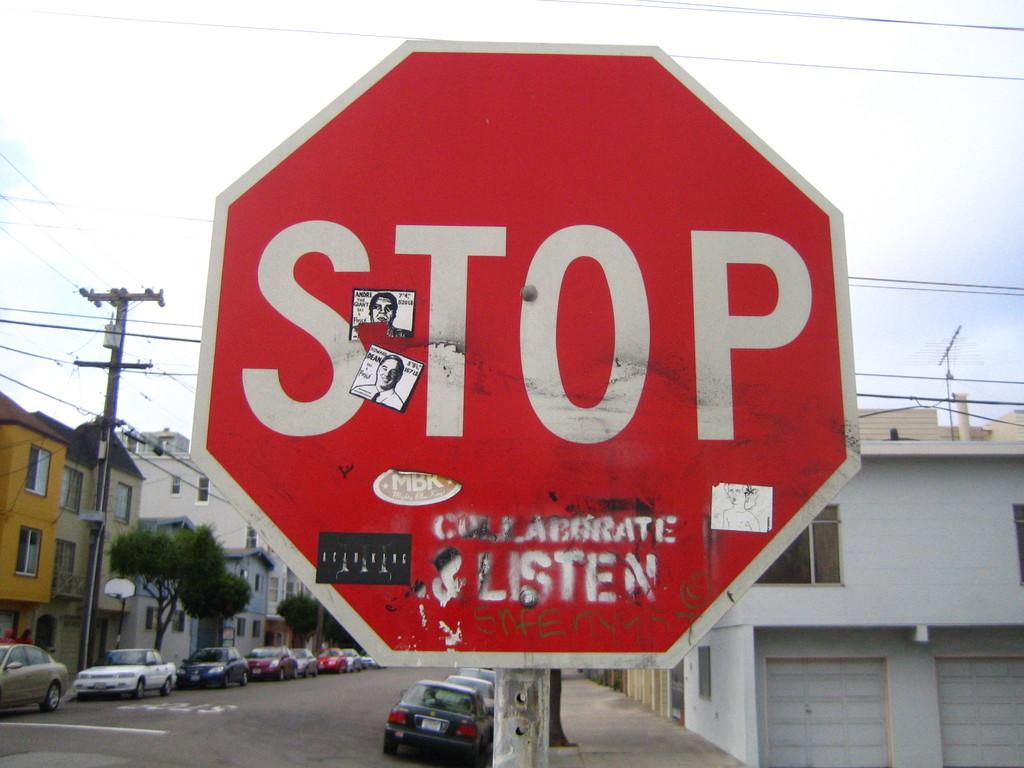<image>
Create a compact narrative representing the image presented. A stop sign that has been vandalized with stickers and paint. 